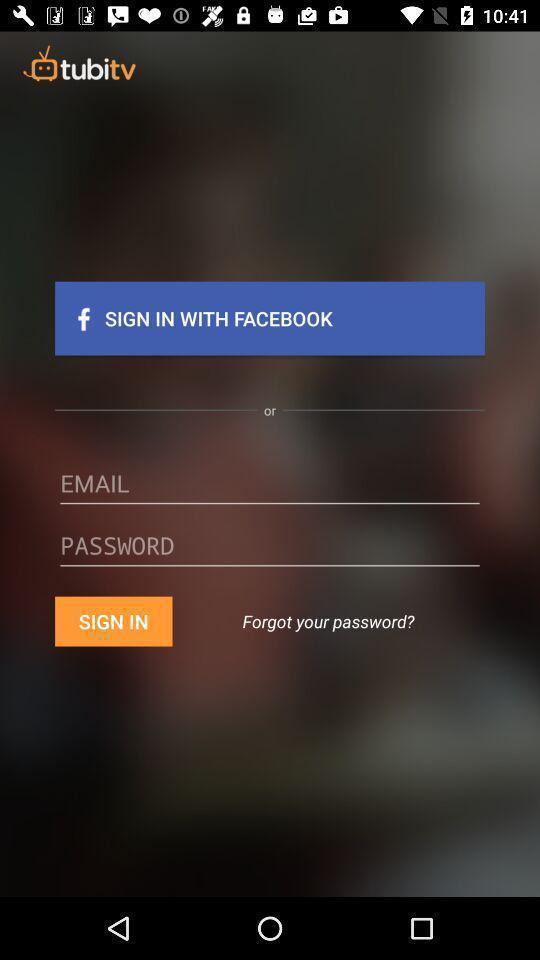Describe this image in words. Sign in page of the application to get access. 